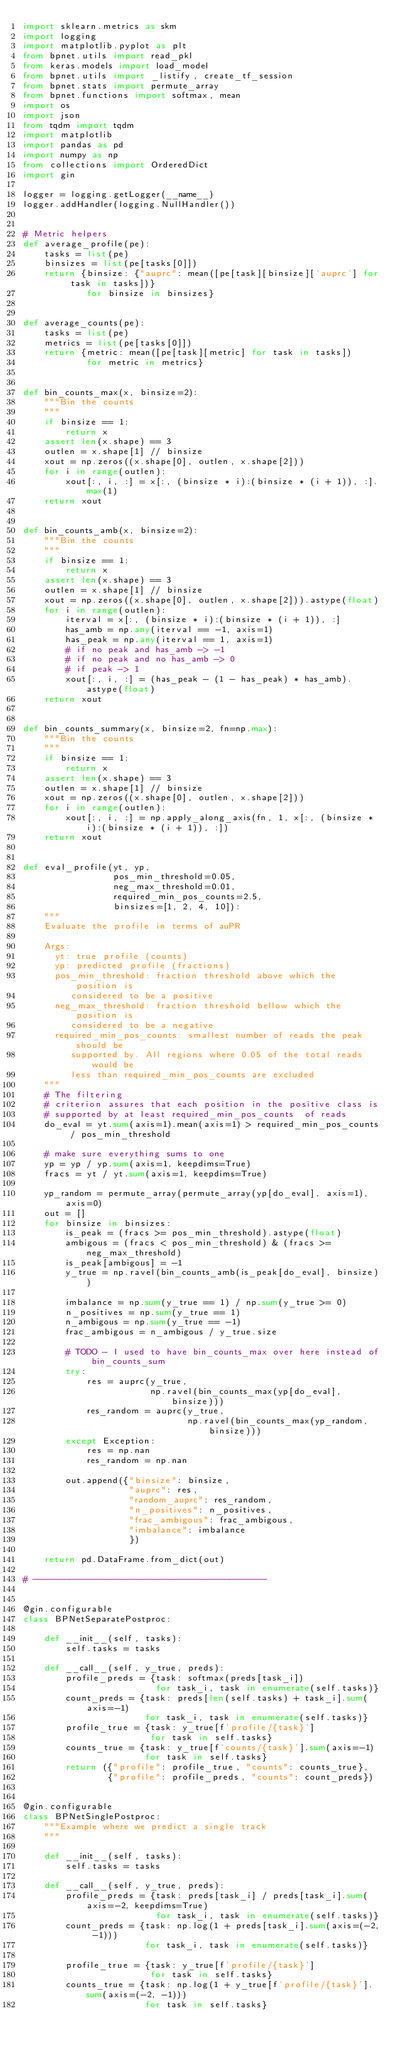Convert code to text. <code><loc_0><loc_0><loc_500><loc_500><_Python_>import sklearn.metrics as skm
import logging
import matplotlib.pyplot as plt
from bpnet.utils import read_pkl
from keras.models import load_model
from bpnet.utils import _listify, create_tf_session
from bpnet.stats import permute_array
from bpnet.functions import softmax, mean
import os
import json
from tqdm import tqdm
import matplotlib
import pandas as pd
import numpy as np
from collections import OrderedDict
import gin

logger = logging.getLogger(__name__)
logger.addHandler(logging.NullHandler())


# Metric helpers
def average_profile(pe):
    tasks = list(pe)
    binsizes = list(pe[tasks[0]])
    return {binsize: {"auprc": mean([pe[task][binsize]['auprc'] for task in tasks])}
            for binsize in binsizes}


def average_counts(pe):
    tasks = list(pe)
    metrics = list(pe[tasks[0]])
    return {metric: mean([pe[task][metric] for task in tasks])
            for metric in metrics}


def bin_counts_max(x, binsize=2):
    """Bin the counts
    """
    if binsize == 1:
        return x
    assert len(x.shape) == 3
    outlen = x.shape[1] // binsize
    xout = np.zeros((x.shape[0], outlen, x.shape[2]))
    for i in range(outlen):
        xout[:, i, :] = x[:, (binsize * i):(binsize * (i + 1)), :].max(1)
    return xout


def bin_counts_amb(x, binsize=2):
    """Bin the counts
    """
    if binsize == 1:
        return x
    assert len(x.shape) == 3
    outlen = x.shape[1] // binsize
    xout = np.zeros((x.shape[0], outlen, x.shape[2])).astype(float)
    for i in range(outlen):
        iterval = x[:, (binsize * i):(binsize * (i + 1)), :]
        has_amb = np.any(iterval == -1, axis=1)
        has_peak = np.any(iterval == 1, axis=1)
        # if no peak and has_amb -> -1
        # if no peak and no has_amb -> 0
        # if peak -> 1
        xout[:, i, :] = (has_peak - (1 - has_peak) * has_amb).astype(float)
    return xout


def bin_counts_summary(x, binsize=2, fn=np.max):
    """Bin the counts
    """
    if binsize == 1:
        return x
    assert len(x.shape) == 3
    outlen = x.shape[1] // binsize
    xout = np.zeros((x.shape[0], outlen, x.shape[2]))
    for i in range(outlen):
        xout[:, i, :] = np.apply_along_axis(fn, 1, x[:, (binsize * i):(binsize * (i + 1)), :])
    return xout


def eval_profile(yt, yp,
                 pos_min_threshold=0.05,
                 neg_max_threshold=0.01,
                 required_min_pos_counts=2.5,
                 binsizes=[1, 2, 4, 10]):
    """
    Evaluate the profile in terms of auPR

    Args:
      yt: true profile (counts)
      yp: predicted profile (fractions)
      pos_min_threshold: fraction threshold above which the position is
         considered to be a positive
      neg_max_threshold: fraction threshold bellow which the position is
         considered to be a negative
      required_min_pos_counts: smallest number of reads the peak should be
         supported by. All regions where 0.05 of the total reads would be
         less than required_min_pos_counts are excluded
    """
    # The filtering
    # criterion assures that each position in the positive class is
    # supported by at least required_min_pos_counts  of reads
    do_eval = yt.sum(axis=1).mean(axis=1) > required_min_pos_counts / pos_min_threshold

    # make sure everything sums to one
    yp = yp / yp.sum(axis=1, keepdims=True)
    fracs = yt / yt.sum(axis=1, keepdims=True)

    yp_random = permute_array(permute_array(yp[do_eval], axis=1), axis=0)
    out = []
    for binsize in binsizes:
        is_peak = (fracs >= pos_min_threshold).astype(float)
        ambigous = (fracs < pos_min_threshold) & (fracs >= neg_max_threshold)
        is_peak[ambigous] = -1
        y_true = np.ravel(bin_counts_amb(is_peak[do_eval], binsize))

        imbalance = np.sum(y_true == 1) / np.sum(y_true >= 0)
        n_positives = np.sum(y_true == 1)
        n_ambigous = np.sum(y_true == -1)
        frac_ambigous = n_ambigous / y_true.size

        # TODO - I used to have bin_counts_max over here instead of bin_counts_sum
        try:
            res = auprc(y_true,
                        np.ravel(bin_counts_max(yp[do_eval], binsize)))
            res_random = auprc(y_true,
                               np.ravel(bin_counts_max(yp_random, binsize)))
        except Exception:
            res = np.nan
            res_random = np.nan

        out.append({"binsize": binsize,
                    "auprc": res,
                    "random_auprc": res_random,
                    "n_positives": n_positives,
                    "frac_ambigous": frac_ambigous,
                    "imbalance": imbalance
                    })

    return pd.DataFrame.from_dict(out)

# --------------------------------------------


@gin.configurable
class BPNetSeparatePostproc:

    def __init__(self, tasks):
        self.tasks = tasks

    def __call__(self, y_true, preds):
        profile_preds = {task: softmax(preds[task_i])
                         for task_i, task in enumerate(self.tasks)}
        count_preds = {task: preds[len(self.tasks) + task_i].sum(axis=-1)
                       for task_i, task in enumerate(self.tasks)}
        profile_true = {task: y_true[f'profile/{task}']
                        for task in self.tasks}
        counts_true = {task: y_true[f'counts/{task}'].sum(axis=-1)
                       for task in self.tasks}
        return ({"profile": profile_true, "counts": counts_true},
                {"profile": profile_preds, "counts": count_preds})


@gin.configurable
class BPNetSinglePostproc:
    """Example where we predict a single track
    """

    def __init__(self, tasks):
        self.tasks = tasks

    def __call__(self, y_true, preds):
        profile_preds = {task: preds[task_i] / preds[task_i].sum(axis=-2, keepdims=True)
                         for task_i, task in enumerate(self.tasks)}
        count_preds = {task: np.log(1 + preds[task_i].sum(axis=(-2, -1)))
                       for task_i, task in enumerate(self.tasks)}

        profile_true = {task: y_true[f'profile/{task}']
                        for task in self.tasks}
        counts_true = {task: np.log(1 + y_true[f'profile/{task}'].sum(axis=(-2, -1)))
                       for task in self.tasks}</code> 